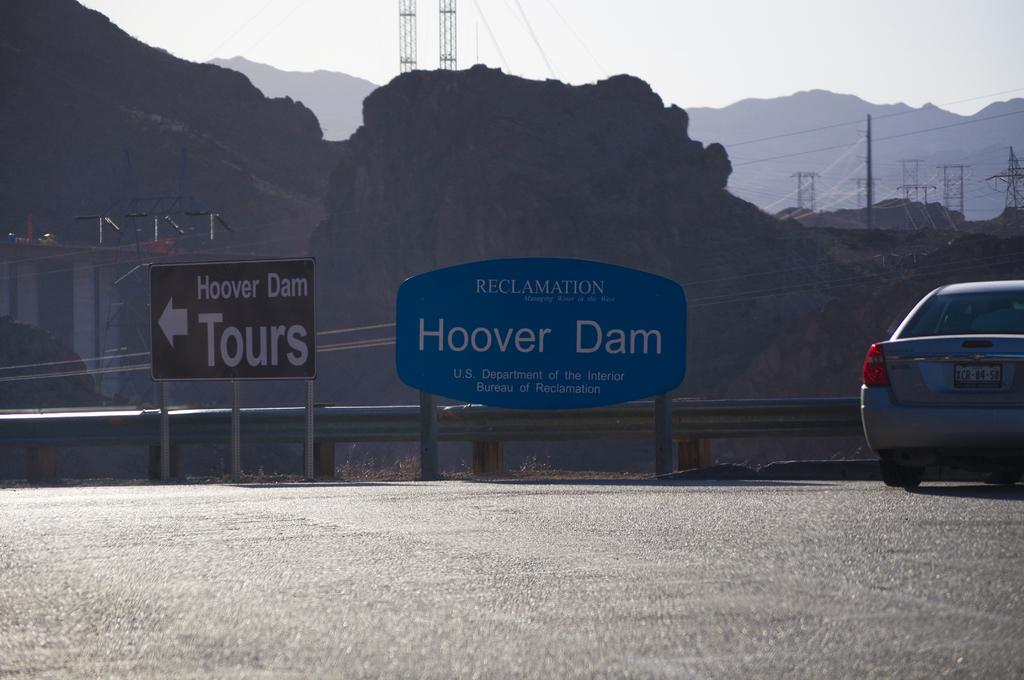What is located on the left side of the road in the image? There is a car on the left side of the road in the image. What can be seen in the middle of the road in the image? There are label boards in the middle of the road in the image. What type of natural feature is visible in the background of the image? There are hills visible in the background of the image. What structures are present in the background of the image? Electric poles are present in the background of the image. What is visible in the sky in the image? The sky is visible in the image. How many apples are hanging from the electric poles in the image? There are no apples present in the image; only electric poles and other elements mentioned in the facts are visible. What type of seed can be seen growing on the hills in the image? There is no mention of seeds or any plant life on the hills in the image. 